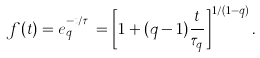Convert formula to latex. <formula><loc_0><loc_0><loc_500><loc_500>f ( t ) = e _ { q } ^ { - t / \tau _ { q } } = \left [ 1 + ( q - 1 ) \frac { t } { \tau _ { q } } \right ] ^ { 1 / ( 1 - q ) } .</formula> 